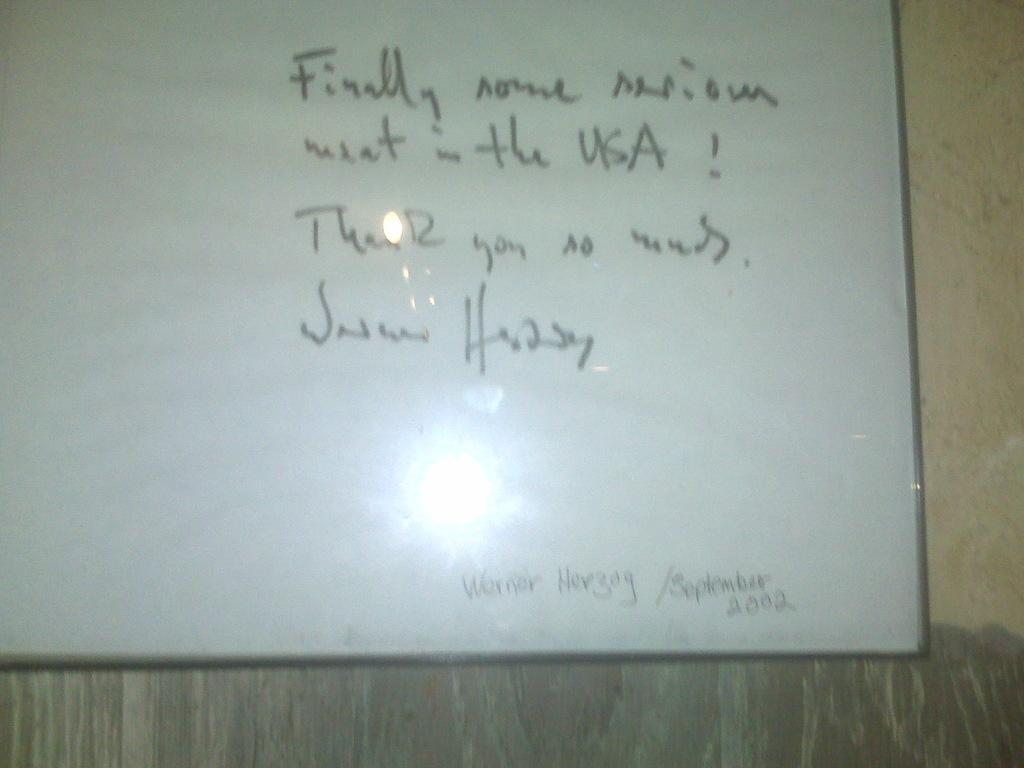<image>
Present a compact description of the photo's key features. Whiteboard which starts off with the word "Finally". 